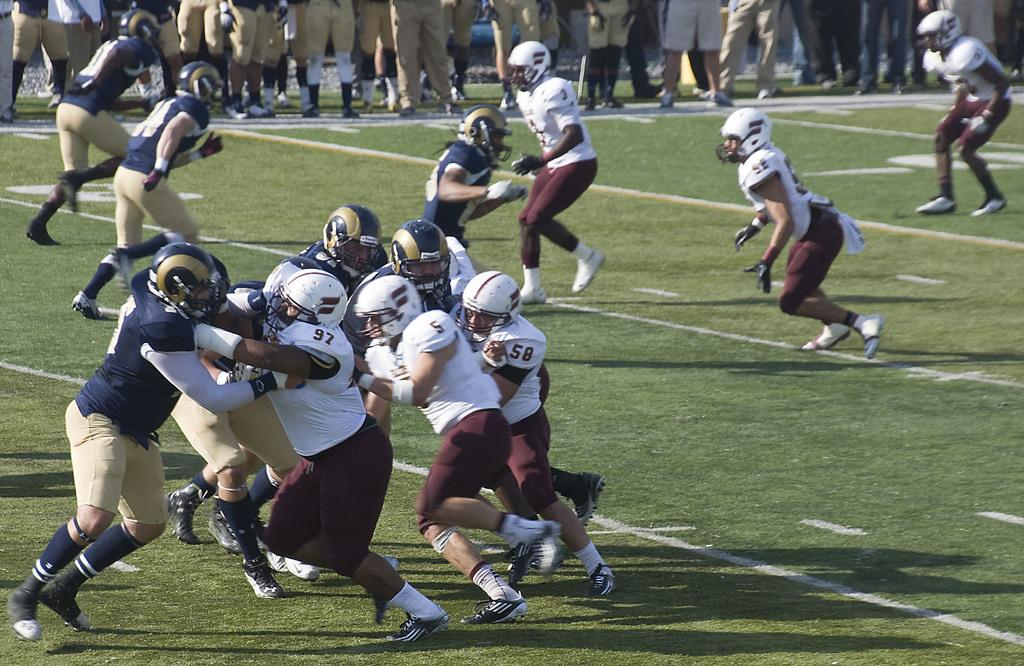What activity are the people in the image engaged in? The people in the image are playing a game. Where are they playing the game? They are playing the game on the ground. What protective gear are the players wearing? The people playing the game are wearing helmets. Can you describe the people in the background of the image? There is a group of people standing in the background of the image. What type of bird can be seen flying over the group of people playing the game in the image? There is no bird visible in the image; it only shows a group of people playing a game on the ground. 